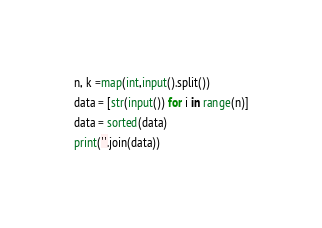Convert code to text. <code><loc_0><loc_0><loc_500><loc_500><_Python_>n, k =map(int,input().split())
data = [str(input()) for i in range(n)]
data = sorted(data)
print(''.join(data))</code> 